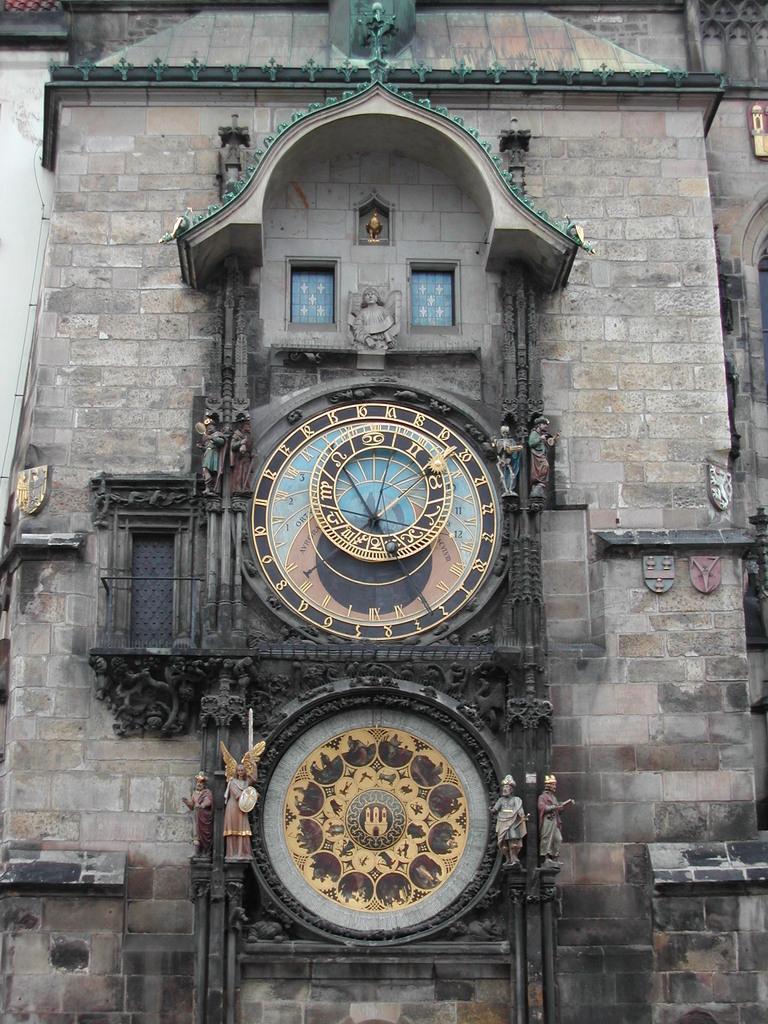Is it possible to read the time on this clock?
Offer a terse response. No. 